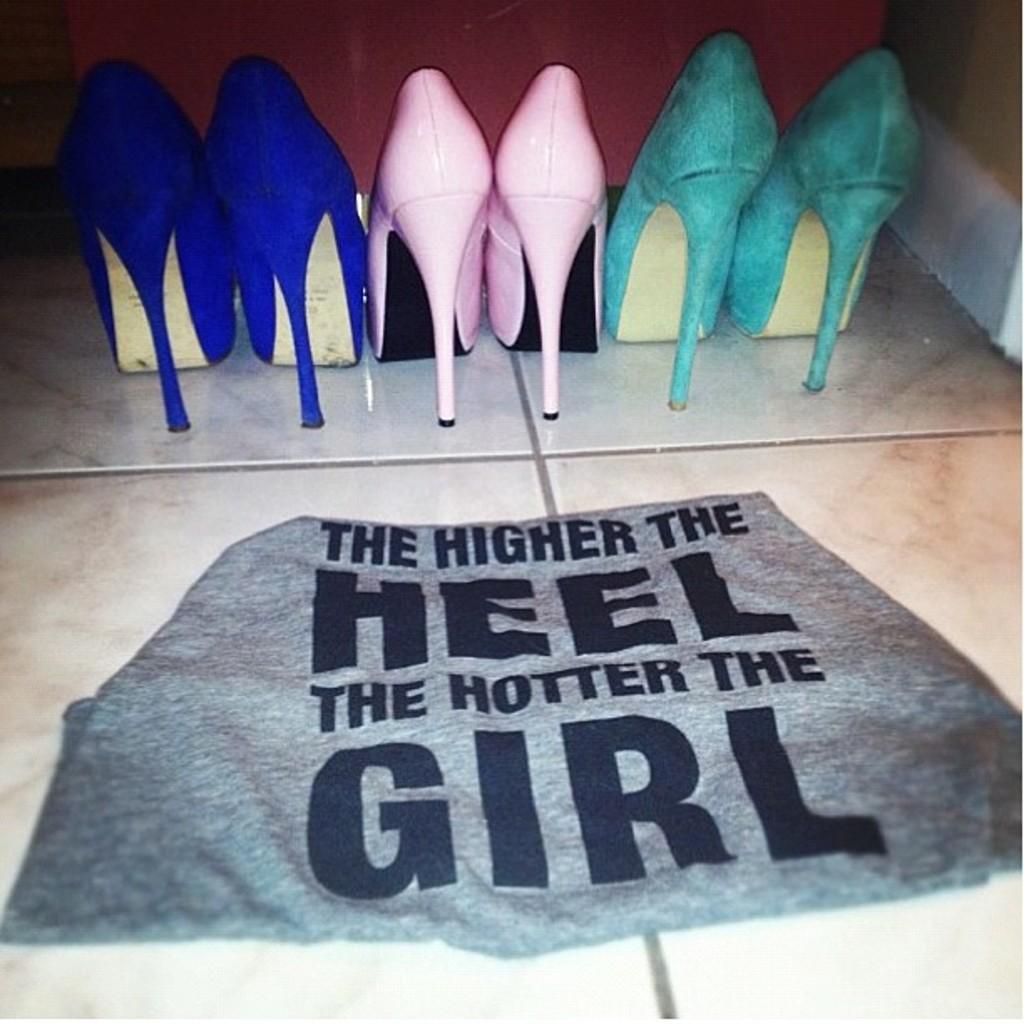Can you describe this image briefly? In this image I can see three pairs of heels. And there is a cloth on the floor. 